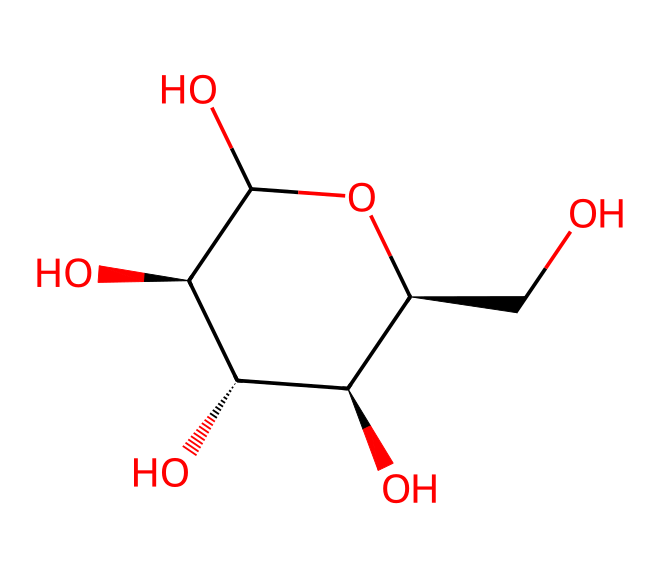How many carbon atoms are in glucose? By examining the SMILES representation, we can count the carbon (C) symbols. The structure shows 6 carbon atoms in total.
Answer: 6 What is the structural form of glucose? The structure indicates that glucose is a hexose, which is a carbohydrate with six carbon atoms arranged in a specific way, and it exists in a cyclic form.
Answer: hexose How many hydroxyl groups are present in glucose? In the SMILES representation, we can identify the hydroxyl groups (–OH) by looking for the 'O' atoms attached to the 'C' atoms. There are 5 hydroxyl groups in total.
Answer: 5 What type of carbohydrate is glucose classified as? Glucose is classified as a monosaccharide, a simple sugar that cannot be hydrolyzed into smaller carbohydrates. Its structure confirms that it is not composed of multiple sugar units.
Answer: monosaccharide What is the molecular formula of glucose? By analyzing the chemical structure or the number of each type of atom, we can determine the molecular formula. Glucose has 6 carbon, 12 hydrogen, and 6 oxygen atoms, leading to its formula C6H12O6.
Answer: C6H12O6 Which functional groups are present in glucose? From the SMILES representation, we can identify multiple –OH (hydroxyl) groups indicating that glucose has alcohol functional groups. The presence of these groups contributes to its solubility and reactivity.
Answer: alcohol groups 